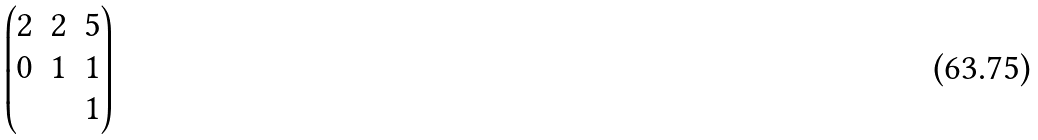<formula> <loc_0><loc_0><loc_500><loc_500>\begin{pmatrix} 2 & 2 & 5 \\ 0 & 1 & 1 \\ & & 1 \end{pmatrix}</formula> 